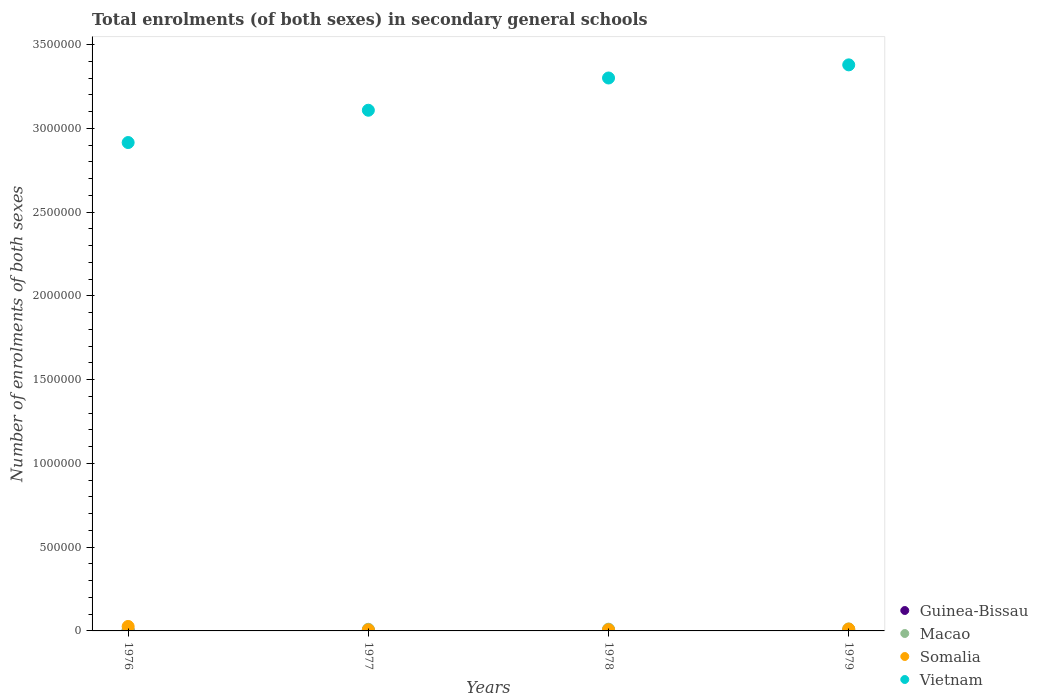How many different coloured dotlines are there?
Your answer should be compact. 4. Is the number of dotlines equal to the number of legend labels?
Your answer should be very brief. Yes. What is the number of enrolments in secondary schools in Guinea-Bissau in 1979?
Your response must be concise. 3666. Across all years, what is the maximum number of enrolments in secondary schools in Macao?
Keep it short and to the point. 1.16e+04. Across all years, what is the minimum number of enrolments in secondary schools in Vietnam?
Ensure brevity in your answer.  2.92e+06. In which year was the number of enrolments in secondary schools in Somalia maximum?
Provide a succinct answer. 1976. In which year was the number of enrolments in secondary schools in Guinea-Bissau minimum?
Your answer should be compact. 1976. What is the total number of enrolments in secondary schools in Macao in the graph?
Your answer should be compact. 3.95e+04. What is the difference between the number of enrolments in secondary schools in Guinea-Bissau in 1976 and that in 1979?
Provide a short and direct response. -1946. What is the difference between the number of enrolments in secondary schools in Somalia in 1979 and the number of enrolments in secondary schools in Vietnam in 1978?
Keep it short and to the point. -3.29e+06. What is the average number of enrolments in secondary schools in Somalia per year?
Your answer should be very brief. 1.28e+04. In the year 1977, what is the difference between the number of enrolments in secondary schools in Macao and number of enrolments in secondary schools in Somalia?
Offer a very short reply. 3393. In how many years, is the number of enrolments in secondary schools in Guinea-Bissau greater than 1800000?
Provide a short and direct response. 0. What is the ratio of the number of enrolments in secondary schools in Guinea-Bissau in 1976 to that in 1977?
Keep it short and to the point. 0.62. Is the difference between the number of enrolments in secondary schools in Macao in 1976 and 1977 greater than the difference between the number of enrolments in secondary schools in Somalia in 1976 and 1977?
Provide a succinct answer. No. What is the difference between the highest and the second highest number of enrolments in secondary schools in Somalia?
Make the answer very short. 1.55e+04. What is the difference between the highest and the lowest number of enrolments in secondary schools in Somalia?
Ensure brevity in your answer.  2.03e+04. Is it the case that in every year, the sum of the number of enrolments in secondary schools in Macao and number of enrolments in secondary schools in Guinea-Bissau  is greater than the sum of number of enrolments in secondary schools in Somalia and number of enrolments in secondary schools in Vietnam?
Provide a short and direct response. No. Is the number of enrolments in secondary schools in Macao strictly less than the number of enrolments in secondary schools in Guinea-Bissau over the years?
Give a very brief answer. No. How many dotlines are there?
Give a very brief answer. 4. How many legend labels are there?
Provide a short and direct response. 4. How are the legend labels stacked?
Offer a very short reply. Vertical. What is the title of the graph?
Provide a succinct answer. Total enrolments (of both sexes) in secondary general schools. What is the label or title of the X-axis?
Make the answer very short. Years. What is the label or title of the Y-axis?
Keep it short and to the point. Number of enrolments of both sexes. What is the Number of enrolments of both sexes of Guinea-Bissau in 1976?
Ensure brevity in your answer.  1720. What is the Number of enrolments of both sexes of Macao in 1976?
Make the answer very short. 7867. What is the Number of enrolments of both sexes in Somalia in 1976?
Provide a short and direct response. 2.66e+04. What is the Number of enrolments of both sexes of Vietnam in 1976?
Your answer should be very brief. 2.92e+06. What is the Number of enrolments of both sexes of Guinea-Bissau in 1977?
Your answer should be very brief. 2785. What is the Number of enrolments of both sexes of Macao in 1977?
Provide a succinct answer. 9701. What is the Number of enrolments of both sexes of Somalia in 1977?
Ensure brevity in your answer.  6308. What is the Number of enrolments of both sexes in Vietnam in 1977?
Make the answer very short. 3.11e+06. What is the Number of enrolments of both sexes in Guinea-Bissau in 1978?
Ensure brevity in your answer.  3371. What is the Number of enrolments of both sexes in Macao in 1978?
Provide a short and direct response. 1.04e+04. What is the Number of enrolments of both sexes of Somalia in 1978?
Your answer should be compact. 6981. What is the Number of enrolments of both sexes in Vietnam in 1978?
Give a very brief answer. 3.30e+06. What is the Number of enrolments of both sexes in Guinea-Bissau in 1979?
Provide a succinct answer. 3666. What is the Number of enrolments of both sexes of Macao in 1979?
Your answer should be compact. 1.16e+04. What is the Number of enrolments of both sexes in Somalia in 1979?
Ensure brevity in your answer.  1.11e+04. What is the Number of enrolments of both sexes in Vietnam in 1979?
Ensure brevity in your answer.  3.38e+06. Across all years, what is the maximum Number of enrolments of both sexes in Guinea-Bissau?
Provide a short and direct response. 3666. Across all years, what is the maximum Number of enrolments of both sexes of Macao?
Ensure brevity in your answer.  1.16e+04. Across all years, what is the maximum Number of enrolments of both sexes in Somalia?
Provide a short and direct response. 2.66e+04. Across all years, what is the maximum Number of enrolments of both sexes in Vietnam?
Your response must be concise. 3.38e+06. Across all years, what is the minimum Number of enrolments of both sexes of Guinea-Bissau?
Your answer should be compact. 1720. Across all years, what is the minimum Number of enrolments of both sexes of Macao?
Keep it short and to the point. 7867. Across all years, what is the minimum Number of enrolments of both sexes in Somalia?
Provide a succinct answer. 6308. Across all years, what is the minimum Number of enrolments of both sexes of Vietnam?
Your answer should be very brief. 2.92e+06. What is the total Number of enrolments of both sexes of Guinea-Bissau in the graph?
Your answer should be compact. 1.15e+04. What is the total Number of enrolments of both sexes of Macao in the graph?
Your answer should be very brief. 3.95e+04. What is the total Number of enrolments of both sexes in Somalia in the graph?
Ensure brevity in your answer.  5.10e+04. What is the total Number of enrolments of both sexes of Vietnam in the graph?
Your answer should be very brief. 1.27e+07. What is the difference between the Number of enrolments of both sexes of Guinea-Bissau in 1976 and that in 1977?
Make the answer very short. -1065. What is the difference between the Number of enrolments of both sexes of Macao in 1976 and that in 1977?
Your response must be concise. -1834. What is the difference between the Number of enrolments of both sexes of Somalia in 1976 and that in 1977?
Your answer should be compact. 2.03e+04. What is the difference between the Number of enrolments of both sexes in Vietnam in 1976 and that in 1977?
Make the answer very short. -1.93e+05. What is the difference between the Number of enrolments of both sexes of Guinea-Bissau in 1976 and that in 1978?
Keep it short and to the point. -1651. What is the difference between the Number of enrolments of both sexes in Macao in 1976 and that in 1978?
Ensure brevity in your answer.  -2502. What is the difference between the Number of enrolments of both sexes of Somalia in 1976 and that in 1978?
Your response must be concise. 1.96e+04. What is the difference between the Number of enrolments of both sexes of Vietnam in 1976 and that in 1978?
Offer a terse response. -3.85e+05. What is the difference between the Number of enrolments of both sexes in Guinea-Bissau in 1976 and that in 1979?
Offer a very short reply. -1946. What is the difference between the Number of enrolments of both sexes in Macao in 1976 and that in 1979?
Your response must be concise. -3698. What is the difference between the Number of enrolments of both sexes of Somalia in 1976 and that in 1979?
Your response must be concise. 1.55e+04. What is the difference between the Number of enrolments of both sexes in Vietnam in 1976 and that in 1979?
Your answer should be compact. -4.64e+05. What is the difference between the Number of enrolments of both sexes of Guinea-Bissau in 1977 and that in 1978?
Give a very brief answer. -586. What is the difference between the Number of enrolments of both sexes of Macao in 1977 and that in 1978?
Your answer should be very brief. -668. What is the difference between the Number of enrolments of both sexes of Somalia in 1977 and that in 1978?
Offer a terse response. -673. What is the difference between the Number of enrolments of both sexes in Vietnam in 1977 and that in 1978?
Provide a succinct answer. -1.93e+05. What is the difference between the Number of enrolments of both sexes in Guinea-Bissau in 1977 and that in 1979?
Ensure brevity in your answer.  -881. What is the difference between the Number of enrolments of both sexes of Macao in 1977 and that in 1979?
Provide a succinct answer. -1864. What is the difference between the Number of enrolments of both sexes of Somalia in 1977 and that in 1979?
Your response must be concise. -4822. What is the difference between the Number of enrolments of both sexes in Vietnam in 1977 and that in 1979?
Offer a terse response. -2.71e+05. What is the difference between the Number of enrolments of both sexes in Guinea-Bissau in 1978 and that in 1979?
Give a very brief answer. -295. What is the difference between the Number of enrolments of both sexes in Macao in 1978 and that in 1979?
Ensure brevity in your answer.  -1196. What is the difference between the Number of enrolments of both sexes in Somalia in 1978 and that in 1979?
Your answer should be very brief. -4149. What is the difference between the Number of enrolments of both sexes in Vietnam in 1978 and that in 1979?
Ensure brevity in your answer.  -7.84e+04. What is the difference between the Number of enrolments of both sexes in Guinea-Bissau in 1976 and the Number of enrolments of both sexes in Macao in 1977?
Offer a very short reply. -7981. What is the difference between the Number of enrolments of both sexes of Guinea-Bissau in 1976 and the Number of enrolments of both sexes of Somalia in 1977?
Keep it short and to the point. -4588. What is the difference between the Number of enrolments of both sexes of Guinea-Bissau in 1976 and the Number of enrolments of both sexes of Vietnam in 1977?
Make the answer very short. -3.11e+06. What is the difference between the Number of enrolments of both sexes of Macao in 1976 and the Number of enrolments of both sexes of Somalia in 1977?
Your response must be concise. 1559. What is the difference between the Number of enrolments of both sexes in Macao in 1976 and the Number of enrolments of both sexes in Vietnam in 1977?
Your answer should be compact. -3.10e+06. What is the difference between the Number of enrolments of both sexes of Somalia in 1976 and the Number of enrolments of both sexes of Vietnam in 1977?
Give a very brief answer. -3.08e+06. What is the difference between the Number of enrolments of both sexes of Guinea-Bissau in 1976 and the Number of enrolments of both sexes of Macao in 1978?
Your answer should be very brief. -8649. What is the difference between the Number of enrolments of both sexes in Guinea-Bissau in 1976 and the Number of enrolments of both sexes in Somalia in 1978?
Provide a short and direct response. -5261. What is the difference between the Number of enrolments of both sexes in Guinea-Bissau in 1976 and the Number of enrolments of both sexes in Vietnam in 1978?
Provide a short and direct response. -3.30e+06. What is the difference between the Number of enrolments of both sexes of Macao in 1976 and the Number of enrolments of both sexes of Somalia in 1978?
Your response must be concise. 886. What is the difference between the Number of enrolments of both sexes in Macao in 1976 and the Number of enrolments of both sexes in Vietnam in 1978?
Your response must be concise. -3.29e+06. What is the difference between the Number of enrolments of both sexes of Somalia in 1976 and the Number of enrolments of both sexes of Vietnam in 1978?
Ensure brevity in your answer.  -3.27e+06. What is the difference between the Number of enrolments of both sexes of Guinea-Bissau in 1976 and the Number of enrolments of both sexes of Macao in 1979?
Your answer should be very brief. -9845. What is the difference between the Number of enrolments of both sexes of Guinea-Bissau in 1976 and the Number of enrolments of both sexes of Somalia in 1979?
Provide a short and direct response. -9410. What is the difference between the Number of enrolments of both sexes in Guinea-Bissau in 1976 and the Number of enrolments of both sexes in Vietnam in 1979?
Make the answer very short. -3.38e+06. What is the difference between the Number of enrolments of both sexes of Macao in 1976 and the Number of enrolments of both sexes of Somalia in 1979?
Provide a succinct answer. -3263. What is the difference between the Number of enrolments of both sexes of Macao in 1976 and the Number of enrolments of both sexes of Vietnam in 1979?
Your response must be concise. -3.37e+06. What is the difference between the Number of enrolments of both sexes of Somalia in 1976 and the Number of enrolments of both sexes of Vietnam in 1979?
Keep it short and to the point. -3.35e+06. What is the difference between the Number of enrolments of both sexes of Guinea-Bissau in 1977 and the Number of enrolments of both sexes of Macao in 1978?
Give a very brief answer. -7584. What is the difference between the Number of enrolments of both sexes of Guinea-Bissau in 1977 and the Number of enrolments of both sexes of Somalia in 1978?
Provide a short and direct response. -4196. What is the difference between the Number of enrolments of both sexes in Guinea-Bissau in 1977 and the Number of enrolments of both sexes in Vietnam in 1978?
Ensure brevity in your answer.  -3.30e+06. What is the difference between the Number of enrolments of both sexes in Macao in 1977 and the Number of enrolments of both sexes in Somalia in 1978?
Provide a succinct answer. 2720. What is the difference between the Number of enrolments of both sexes in Macao in 1977 and the Number of enrolments of both sexes in Vietnam in 1978?
Provide a short and direct response. -3.29e+06. What is the difference between the Number of enrolments of both sexes of Somalia in 1977 and the Number of enrolments of both sexes of Vietnam in 1978?
Make the answer very short. -3.29e+06. What is the difference between the Number of enrolments of both sexes of Guinea-Bissau in 1977 and the Number of enrolments of both sexes of Macao in 1979?
Provide a succinct answer. -8780. What is the difference between the Number of enrolments of both sexes of Guinea-Bissau in 1977 and the Number of enrolments of both sexes of Somalia in 1979?
Ensure brevity in your answer.  -8345. What is the difference between the Number of enrolments of both sexes in Guinea-Bissau in 1977 and the Number of enrolments of both sexes in Vietnam in 1979?
Ensure brevity in your answer.  -3.38e+06. What is the difference between the Number of enrolments of both sexes of Macao in 1977 and the Number of enrolments of both sexes of Somalia in 1979?
Your response must be concise. -1429. What is the difference between the Number of enrolments of both sexes in Macao in 1977 and the Number of enrolments of both sexes in Vietnam in 1979?
Keep it short and to the point. -3.37e+06. What is the difference between the Number of enrolments of both sexes of Somalia in 1977 and the Number of enrolments of both sexes of Vietnam in 1979?
Your answer should be very brief. -3.37e+06. What is the difference between the Number of enrolments of both sexes in Guinea-Bissau in 1978 and the Number of enrolments of both sexes in Macao in 1979?
Offer a terse response. -8194. What is the difference between the Number of enrolments of both sexes of Guinea-Bissau in 1978 and the Number of enrolments of both sexes of Somalia in 1979?
Your response must be concise. -7759. What is the difference between the Number of enrolments of both sexes of Guinea-Bissau in 1978 and the Number of enrolments of both sexes of Vietnam in 1979?
Ensure brevity in your answer.  -3.38e+06. What is the difference between the Number of enrolments of both sexes of Macao in 1978 and the Number of enrolments of both sexes of Somalia in 1979?
Your answer should be very brief. -761. What is the difference between the Number of enrolments of both sexes in Macao in 1978 and the Number of enrolments of both sexes in Vietnam in 1979?
Your answer should be very brief. -3.37e+06. What is the difference between the Number of enrolments of both sexes of Somalia in 1978 and the Number of enrolments of both sexes of Vietnam in 1979?
Give a very brief answer. -3.37e+06. What is the average Number of enrolments of both sexes in Guinea-Bissau per year?
Ensure brevity in your answer.  2885.5. What is the average Number of enrolments of both sexes of Macao per year?
Give a very brief answer. 9875.5. What is the average Number of enrolments of both sexes of Somalia per year?
Provide a short and direct response. 1.28e+04. What is the average Number of enrolments of both sexes in Vietnam per year?
Provide a short and direct response. 3.18e+06. In the year 1976, what is the difference between the Number of enrolments of both sexes of Guinea-Bissau and Number of enrolments of both sexes of Macao?
Ensure brevity in your answer.  -6147. In the year 1976, what is the difference between the Number of enrolments of both sexes of Guinea-Bissau and Number of enrolments of both sexes of Somalia?
Give a very brief answer. -2.49e+04. In the year 1976, what is the difference between the Number of enrolments of both sexes in Guinea-Bissau and Number of enrolments of both sexes in Vietnam?
Make the answer very short. -2.91e+06. In the year 1976, what is the difference between the Number of enrolments of both sexes of Macao and Number of enrolments of both sexes of Somalia?
Ensure brevity in your answer.  -1.87e+04. In the year 1976, what is the difference between the Number of enrolments of both sexes in Macao and Number of enrolments of both sexes in Vietnam?
Ensure brevity in your answer.  -2.91e+06. In the year 1976, what is the difference between the Number of enrolments of both sexes of Somalia and Number of enrolments of both sexes of Vietnam?
Make the answer very short. -2.89e+06. In the year 1977, what is the difference between the Number of enrolments of both sexes of Guinea-Bissau and Number of enrolments of both sexes of Macao?
Provide a succinct answer. -6916. In the year 1977, what is the difference between the Number of enrolments of both sexes of Guinea-Bissau and Number of enrolments of both sexes of Somalia?
Give a very brief answer. -3523. In the year 1977, what is the difference between the Number of enrolments of both sexes of Guinea-Bissau and Number of enrolments of both sexes of Vietnam?
Your answer should be very brief. -3.11e+06. In the year 1977, what is the difference between the Number of enrolments of both sexes in Macao and Number of enrolments of both sexes in Somalia?
Offer a terse response. 3393. In the year 1977, what is the difference between the Number of enrolments of both sexes of Macao and Number of enrolments of both sexes of Vietnam?
Ensure brevity in your answer.  -3.10e+06. In the year 1977, what is the difference between the Number of enrolments of both sexes of Somalia and Number of enrolments of both sexes of Vietnam?
Offer a terse response. -3.10e+06. In the year 1978, what is the difference between the Number of enrolments of both sexes of Guinea-Bissau and Number of enrolments of both sexes of Macao?
Your answer should be compact. -6998. In the year 1978, what is the difference between the Number of enrolments of both sexes in Guinea-Bissau and Number of enrolments of both sexes in Somalia?
Make the answer very short. -3610. In the year 1978, what is the difference between the Number of enrolments of both sexes in Guinea-Bissau and Number of enrolments of both sexes in Vietnam?
Give a very brief answer. -3.30e+06. In the year 1978, what is the difference between the Number of enrolments of both sexes of Macao and Number of enrolments of both sexes of Somalia?
Ensure brevity in your answer.  3388. In the year 1978, what is the difference between the Number of enrolments of both sexes of Macao and Number of enrolments of both sexes of Vietnam?
Keep it short and to the point. -3.29e+06. In the year 1978, what is the difference between the Number of enrolments of both sexes in Somalia and Number of enrolments of both sexes in Vietnam?
Your answer should be compact. -3.29e+06. In the year 1979, what is the difference between the Number of enrolments of both sexes of Guinea-Bissau and Number of enrolments of both sexes of Macao?
Make the answer very short. -7899. In the year 1979, what is the difference between the Number of enrolments of both sexes of Guinea-Bissau and Number of enrolments of both sexes of Somalia?
Your response must be concise. -7464. In the year 1979, what is the difference between the Number of enrolments of both sexes in Guinea-Bissau and Number of enrolments of both sexes in Vietnam?
Make the answer very short. -3.38e+06. In the year 1979, what is the difference between the Number of enrolments of both sexes in Macao and Number of enrolments of both sexes in Somalia?
Your response must be concise. 435. In the year 1979, what is the difference between the Number of enrolments of both sexes in Macao and Number of enrolments of both sexes in Vietnam?
Offer a terse response. -3.37e+06. In the year 1979, what is the difference between the Number of enrolments of both sexes in Somalia and Number of enrolments of both sexes in Vietnam?
Your answer should be compact. -3.37e+06. What is the ratio of the Number of enrolments of both sexes of Guinea-Bissau in 1976 to that in 1977?
Give a very brief answer. 0.62. What is the ratio of the Number of enrolments of both sexes of Macao in 1976 to that in 1977?
Offer a very short reply. 0.81. What is the ratio of the Number of enrolments of both sexes in Somalia in 1976 to that in 1977?
Provide a succinct answer. 4.22. What is the ratio of the Number of enrolments of both sexes of Vietnam in 1976 to that in 1977?
Offer a terse response. 0.94. What is the ratio of the Number of enrolments of both sexes of Guinea-Bissau in 1976 to that in 1978?
Your answer should be compact. 0.51. What is the ratio of the Number of enrolments of both sexes in Macao in 1976 to that in 1978?
Make the answer very short. 0.76. What is the ratio of the Number of enrolments of both sexes of Somalia in 1976 to that in 1978?
Make the answer very short. 3.81. What is the ratio of the Number of enrolments of both sexes of Vietnam in 1976 to that in 1978?
Offer a terse response. 0.88. What is the ratio of the Number of enrolments of both sexes of Guinea-Bissau in 1976 to that in 1979?
Ensure brevity in your answer.  0.47. What is the ratio of the Number of enrolments of both sexes in Macao in 1976 to that in 1979?
Give a very brief answer. 0.68. What is the ratio of the Number of enrolments of both sexes in Somalia in 1976 to that in 1979?
Your answer should be very brief. 2.39. What is the ratio of the Number of enrolments of both sexes of Vietnam in 1976 to that in 1979?
Your answer should be compact. 0.86. What is the ratio of the Number of enrolments of both sexes of Guinea-Bissau in 1977 to that in 1978?
Your answer should be compact. 0.83. What is the ratio of the Number of enrolments of both sexes in Macao in 1977 to that in 1978?
Ensure brevity in your answer.  0.94. What is the ratio of the Number of enrolments of both sexes in Somalia in 1977 to that in 1978?
Your response must be concise. 0.9. What is the ratio of the Number of enrolments of both sexes in Vietnam in 1977 to that in 1978?
Provide a short and direct response. 0.94. What is the ratio of the Number of enrolments of both sexes of Guinea-Bissau in 1977 to that in 1979?
Provide a succinct answer. 0.76. What is the ratio of the Number of enrolments of both sexes in Macao in 1977 to that in 1979?
Offer a very short reply. 0.84. What is the ratio of the Number of enrolments of both sexes in Somalia in 1977 to that in 1979?
Keep it short and to the point. 0.57. What is the ratio of the Number of enrolments of both sexes in Vietnam in 1977 to that in 1979?
Make the answer very short. 0.92. What is the ratio of the Number of enrolments of both sexes in Guinea-Bissau in 1978 to that in 1979?
Offer a very short reply. 0.92. What is the ratio of the Number of enrolments of both sexes of Macao in 1978 to that in 1979?
Your answer should be very brief. 0.9. What is the ratio of the Number of enrolments of both sexes of Somalia in 1978 to that in 1979?
Ensure brevity in your answer.  0.63. What is the ratio of the Number of enrolments of both sexes of Vietnam in 1978 to that in 1979?
Your answer should be very brief. 0.98. What is the difference between the highest and the second highest Number of enrolments of both sexes in Guinea-Bissau?
Your answer should be very brief. 295. What is the difference between the highest and the second highest Number of enrolments of both sexes in Macao?
Provide a short and direct response. 1196. What is the difference between the highest and the second highest Number of enrolments of both sexes of Somalia?
Keep it short and to the point. 1.55e+04. What is the difference between the highest and the second highest Number of enrolments of both sexes of Vietnam?
Provide a succinct answer. 7.84e+04. What is the difference between the highest and the lowest Number of enrolments of both sexes of Guinea-Bissau?
Your answer should be very brief. 1946. What is the difference between the highest and the lowest Number of enrolments of both sexes of Macao?
Offer a terse response. 3698. What is the difference between the highest and the lowest Number of enrolments of both sexes of Somalia?
Keep it short and to the point. 2.03e+04. What is the difference between the highest and the lowest Number of enrolments of both sexes in Vietnam?
Your response must be concise. 4.64e+05. 